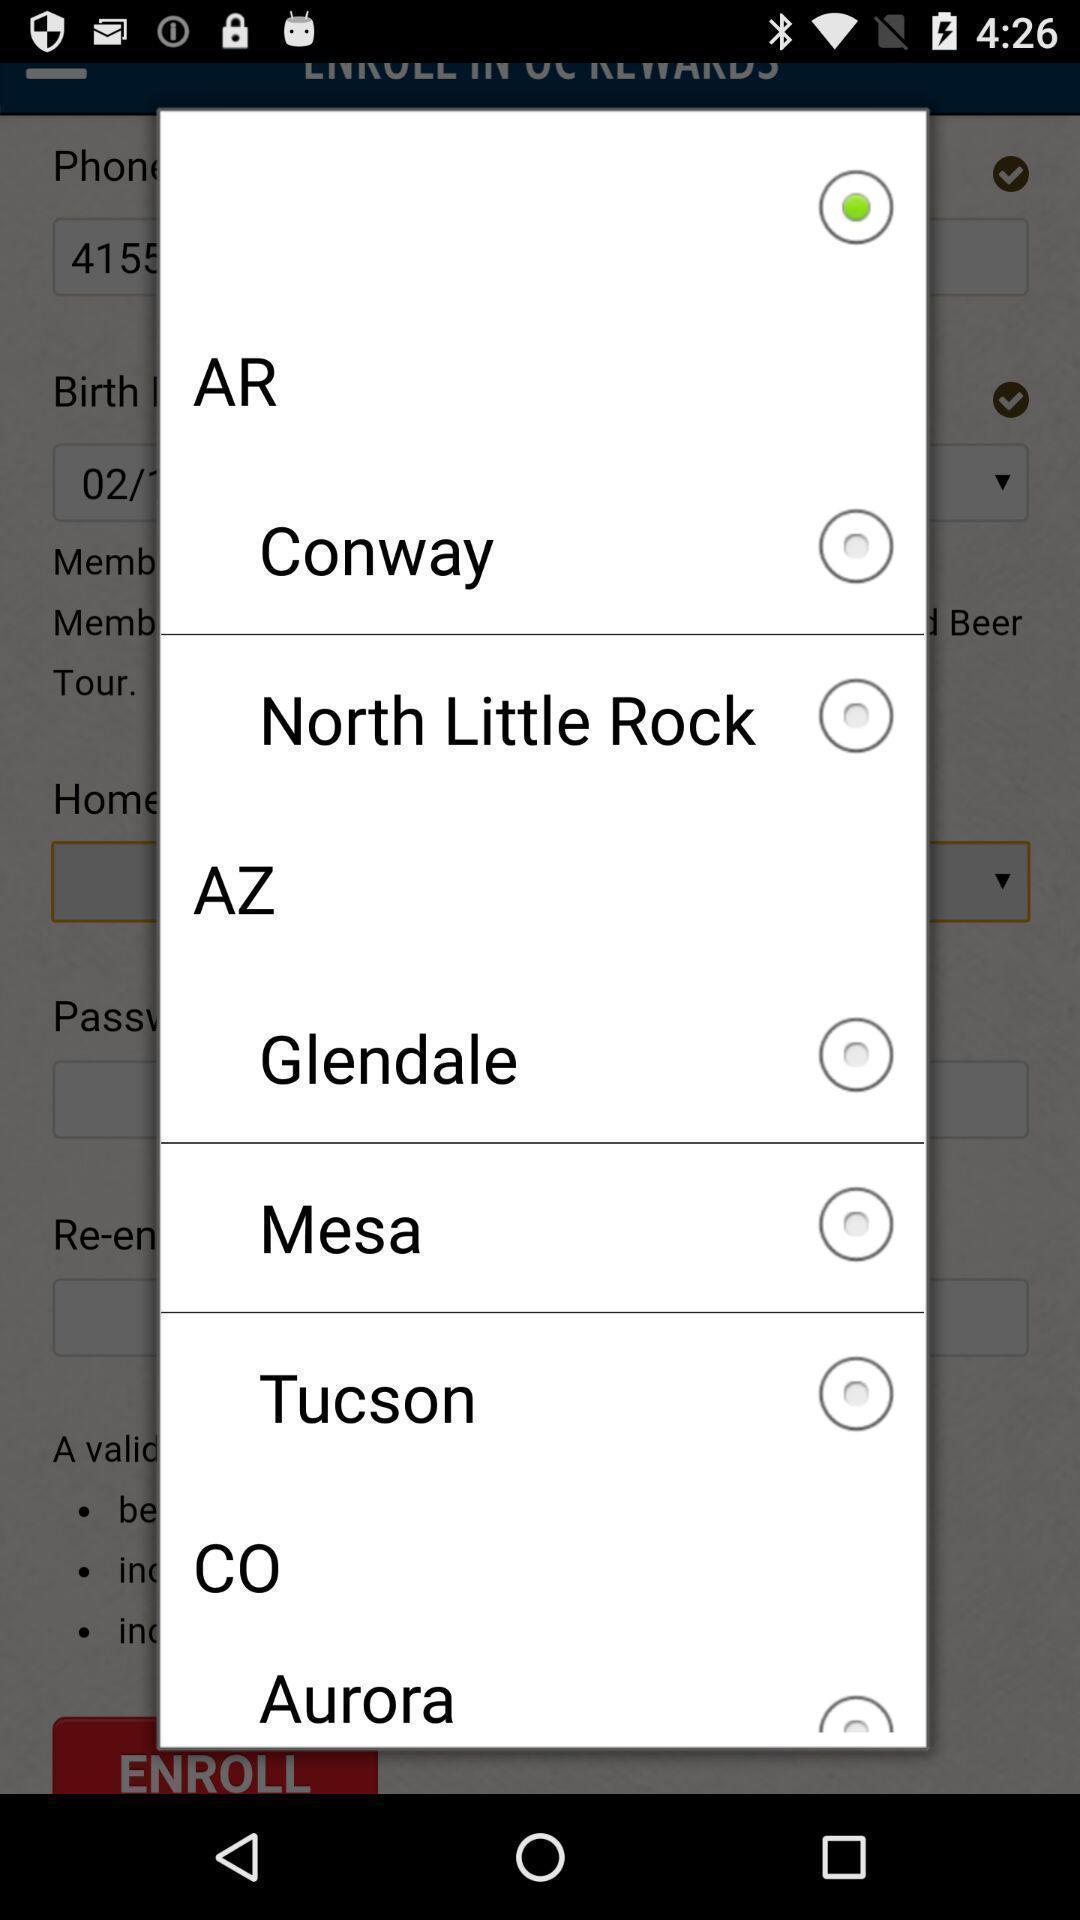Summarize the information in this screenshot. Pop up displaying multiple options. 